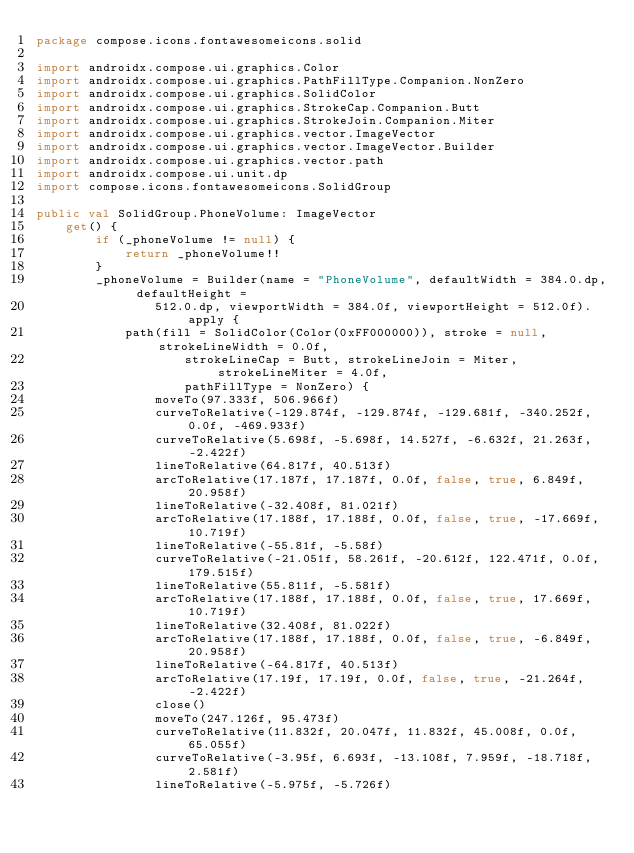<code> <loc_0><loc_0><loc_500><loc_500><_Kotlin_>package compose.icons.fontawesomeicons.solid

import androidx.compose.ui.graphics.Color
import androidx.compose.ui.graphics.PathFillType.Companion.NonZero
import androidx.compose.ui.graphics.SolidColor
import androidx.compose.ui.graphics.StrokeCap.Companion.Butt
import androidx.compose.ui.graphics.StrokeJoin.Companion.Miter
import androidx.compose.ui.graphics.vector.ImageVector
import androidx.compose.ui.graphics.vector.ImageVector.Builder
import androidx.compose.ui.graphics.vector.path
import androidx.compose.ui.unit.dp
import compose.icons.fontawesomeicons.SolidGroup

public val SolidGroup.PhoneVolume: ImageVector
    get() {
        if (_phoneVolume != null) {
            return _phoneVolume!!
        }
        _phoneVolume = Builder(name = "PhoneVolume", defaultWidth = 384.0.dp, defaultHeight =
                512.0.dp, viewportWidth = 384.0f, viewportHeight = 512.0f).apply {
            path(fill = SolidColor(Color(0xFF000000)), stroke = null, strokeLineWidth = 0.0f,
                    strokeLineCap = Butt, strokeLineJoin = Miter, strokeLineMiter = 4.0f,
                    pathFillType = NonZero) {
                moveTo(97.333f, 506.966f)
                curveToRelative(-129.874f, -129.874f, -129.681f, -340.252f, 0.0f, -469.933f)
                curveToRelative(5.698f, -5.698f, 14.527f, -6.632f, 21.263f, -2.422f)
                lineToRelative(64.817f, 40.513f)
                arcToRelative(17.187f, 17.187f, 0.0f, false, true, 6.849f, 20.958f)
                lineToRelative(-32.408f, 81.021f)
                arcToRelative(17.188f, 17.188f, 0.0f, false, true, -17.669f, 10.719f)
                lineToRelative(-55.81f, -5.58f)
                curveToRelative(-21.051f, 58.261f, -20.612f, 122.471f, 0.0f, 179.515f)
                lineToRelative(55.811f, -5.581f)
                arcToRelative(17.188f, 17.188f, 0.0f, false, true, 17.669f, 10.719f)
                lineToRelative(32.408f, 81.022f)
                arcToRelative(17.188f, 17.188f, 0.0f, false, true, -6.849f, 20.958f)
                lineToRelative(-64.817f, 40.513f)
                arcToRelative(17.19f, 17.19f, 0.0f, false, true, -21.264f, -2.422f)
                close()
                moveTo(247.126f, 95.473f)
                curveToRelative(11.832f, 20.047f, 11.832f, 45.008f, 0.0f, 65.055f)
                curveToRelative(-3.95f, 6.693f, -13.108f, 7.959f, -18.718f, 2.581f)
                lineToRelative(-5.975f, -5.726f)</code> 